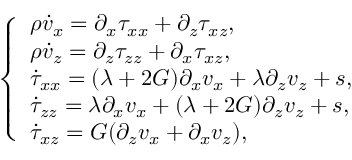Convert formula to latex. <formula><loc_0><loc_0><loc_500><loc_500>\left \{ \begin{array} { l l } { \rho \dot { v } _ { x } = \partial _ { x } \tau _ { x x } + \partial _ { z } \tau _ { x z } , } \\ { \rho \dot { v } _ { z } = \partial _ { z } \tau _ { z z } + \partial _ { x } \tau _ { x z } , } \\ { \dot { \tau } _ { x x } = ( \lambda + 2 G ) \partial _ { x } v _ { x } + \lambda \partial _ { z } v _ { z } + s , } \\ { \dot { \tau } _ { z z } = \lambda \partial _ { x } v _ { x } + ( \lambda + 2 G ) \partial _ { z } v _ { z } + s , } \\ { \dot { \tau } _ { x z } = G ( \partial _ { z } v _ { x } + \partial _ { x } v _ { z } ) , } \end{array}</formula> 